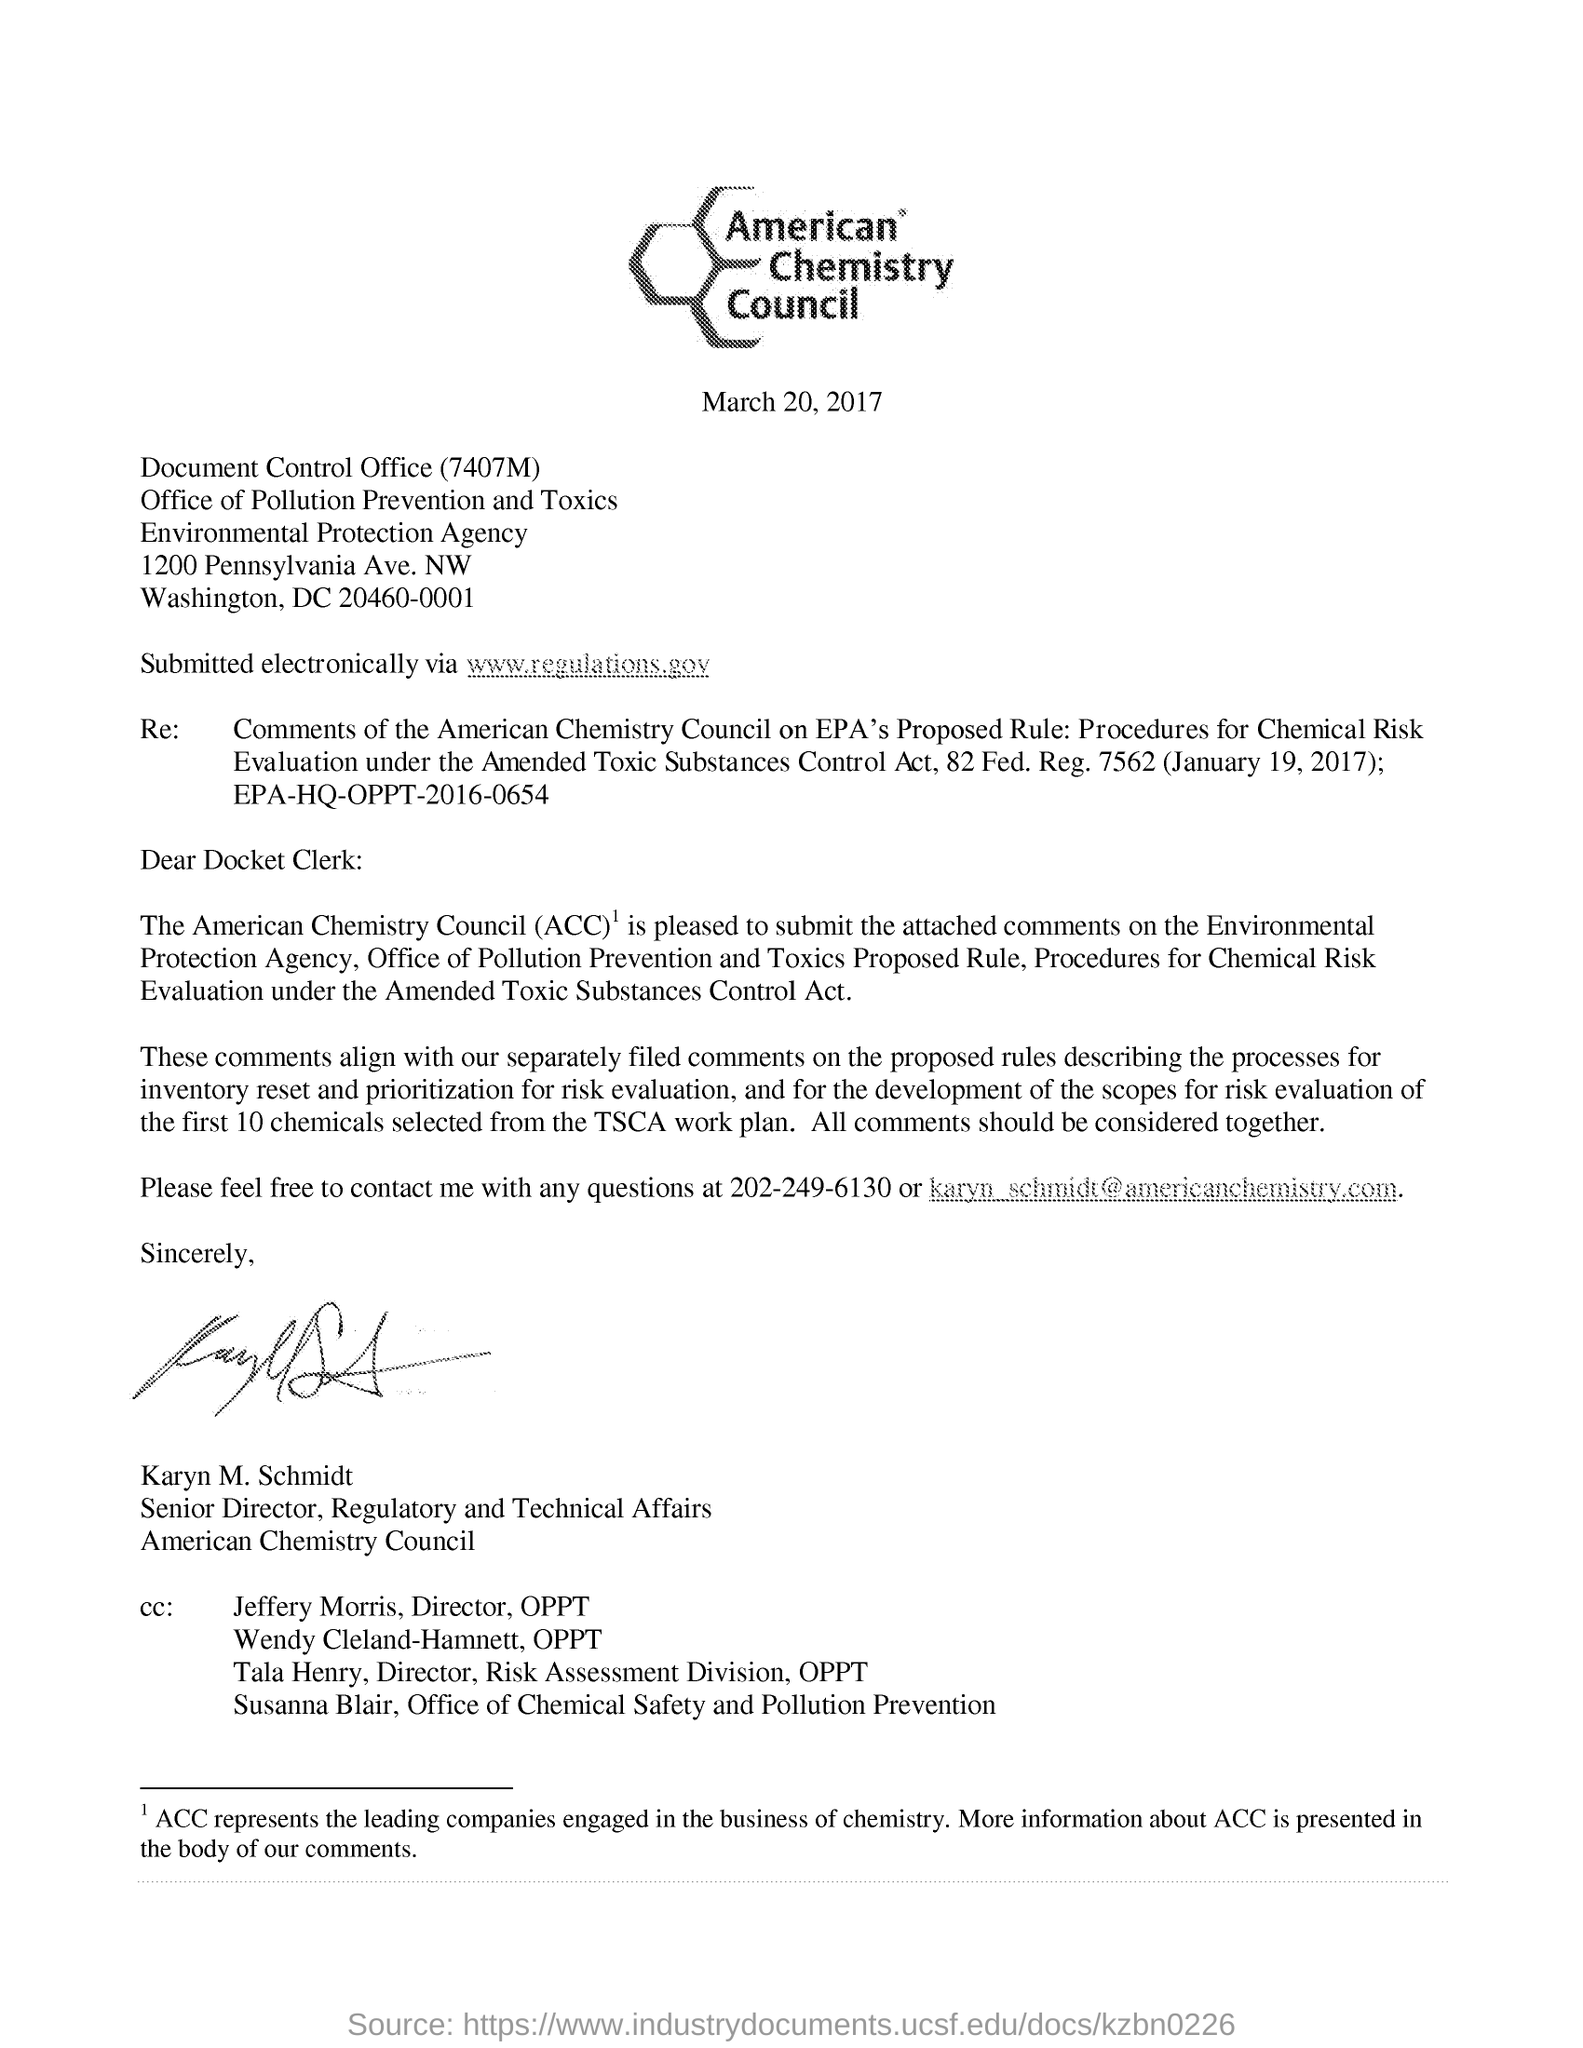What does acc stands for?
Your answer should be compact. American Chemistry Council. What is the regulation for amended toxic substances control act?
Your answer should be compact. 7562. In which number should Karyn M. Schmidt be contacted?
Your answer should be very brief. 202-249-6130. Which contact number is provided in this letter?
Make the answer very short. 202-249-6130. Who is senior director for regulatory and technical affairs american chemistry council?
Provide a succinct answer. Karyn m. schmidt. 